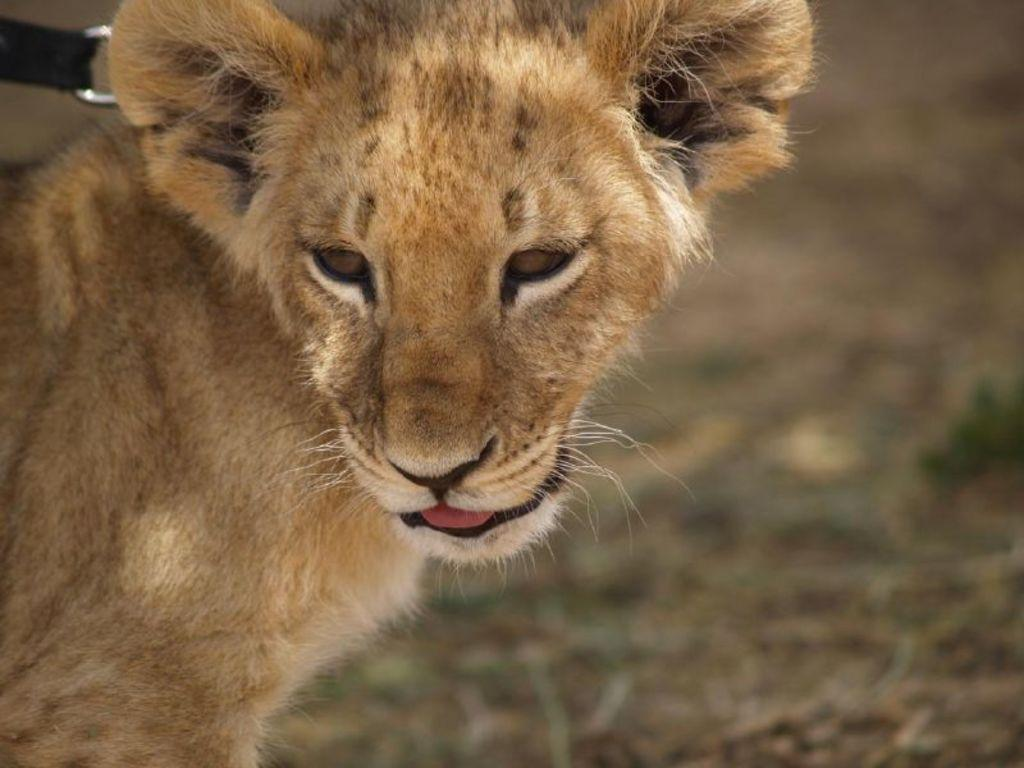What type of animal is in the image? The animal in the image has brown, white, and black colors, but the specific type cannot be determined from the provided facts. Can you describe the color pattern of the animal? The animal has brown, white, and black colors. What can be said about the background of the image? The background of the image is blurred. What is the value of the camp in the image? There is no camp present in the image, so it is not possible to determine its value. 